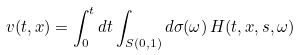Convert formula to latex. <formula><loc_0><loc_0><loc_500><loc_500>v ( t , x ) = \int _ { 0 } ^ { t } d t \int _ { S ( 0 , 1 ) } d \sigma ( \omega ) \, H ( t , x , s , \omega )</formula> 